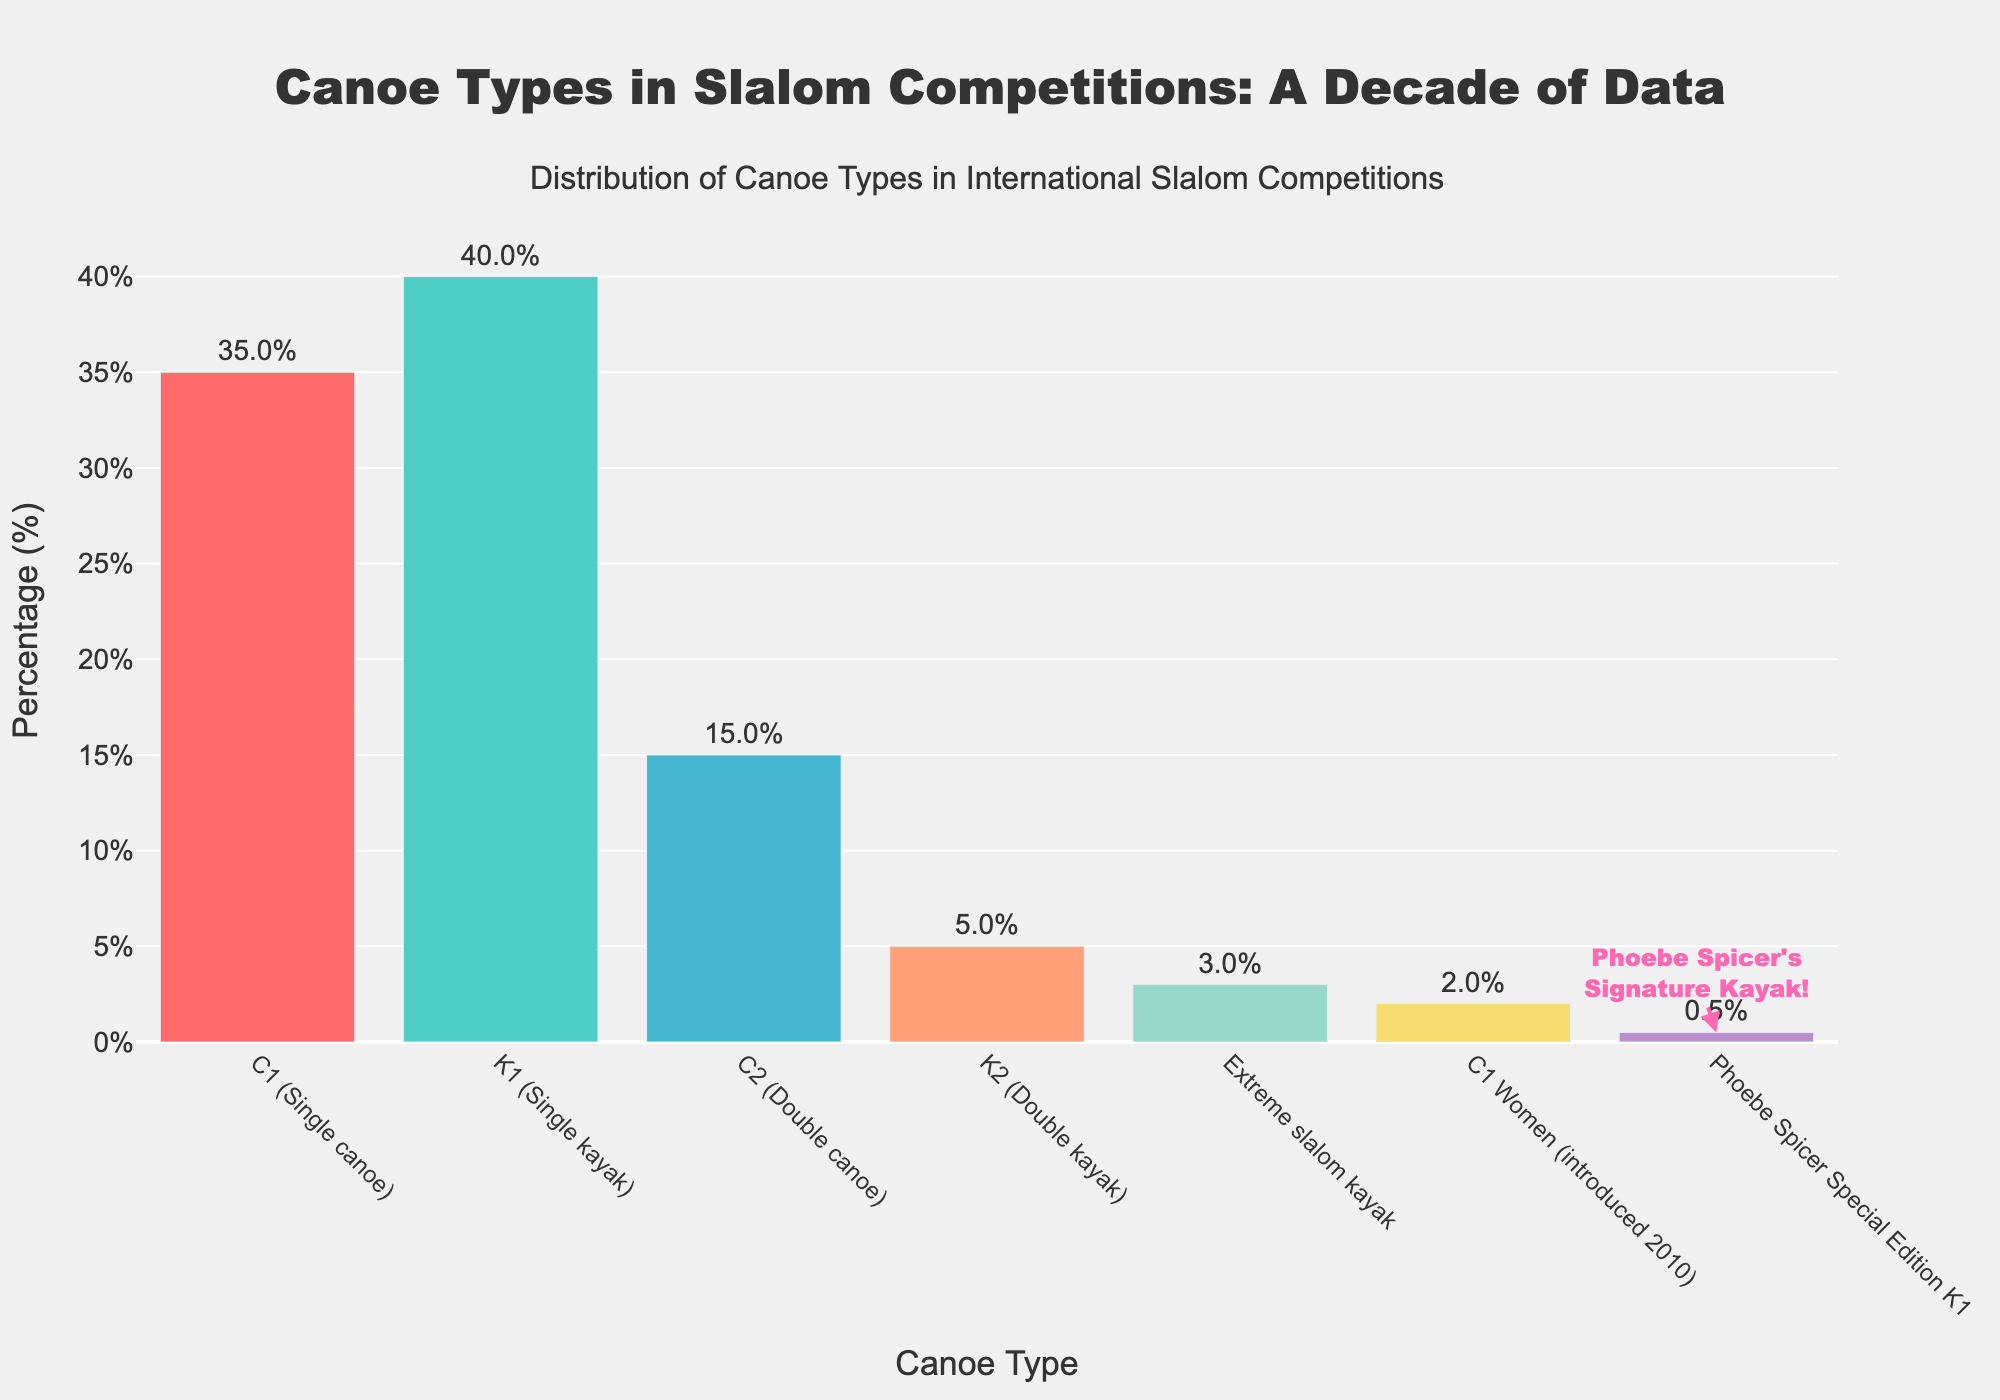What is the most commonly used canoe type in international slalom competitions? The bar chart shows the distribution of different canoe types, and the tallest bar represents the most commonly used canoe type. The K1 (Single kayak) has the highest percentage, indicating it is the most commonly used.
Answer: K1 (Single kayak) How much higher is the percentage of K1 (Single kayak) compared to C1 (Single canoe)? The chart shows K1 (Single kayak) at 40% and C1 (Single canoe) at 35%. Subtracting the percentage of C1 from K1 gives 40% - 35% = 5%.
Answer: 5% What is the combined percentage of extreme slalom kayak and the Phoebe Spicer Special Edition K1? The chart indicates extreme slalom kayak at 3% and the Phoebe Spicer Special Edition K1 at 0.5%. Adding these gives 3% + 0.5% = 3.5%.
Answer: 3.5% Which canoe type introduced in 2010 has the lowest usage, and what is its percentage? The C1 Women, introduced in 2010, is indicated with a percentage of 2% in the chart, making it the lowest among the more recently introduced types.
Answer: C1 Women, 2% How does the usage of C2 (Double canoe) compare to K2 (Double kayak)? The chart shows C2 (Double canoe) at 15% and K2 (Double kayak) at 5%. Since 15% is higher than 5%, C2 is more frequently used than K2.
Answer: C2 is more used than K2 What is the total percentage of canoe types that have a usage below 5%? The chart displays the following canoe types below 5%: K2 (Double kayak) at 5%, extreme slalom kayak at 3%, C1 Women at 2%, and Phoebe Spicer Special Edition K1 at 0.5%. Summing these gives 5% + 3% + 2% + 0.5% = 10.5%.
Answer: 10.5% Which canoe type has an annotation, and what does the annotation say? The chart has an annotation pointing to the Phoebe Spicer Special Edition K1 bar, stating "Phoebe Spicer's<br>Signature Kayak!".
Answer: Phoebe Spicer Special Edition K1, "Phoebe Spicer's<br>Signature Kayak!" Which bar represents a canoe type that has a percentage less than 1%, and what is the specific value? The bar for Phoebe Spicer Special Edition K1 represents a canoe type with a percentage of 0.5%, which is less than 1%.
Answer: Phoebe Spicer Special Edition K1, 0.5% 